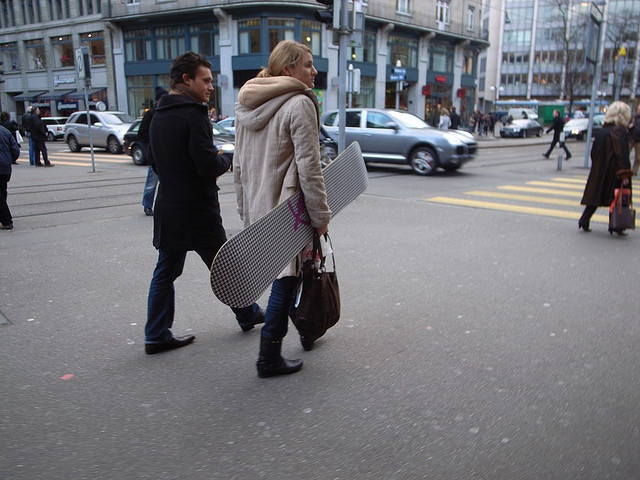Describe the objects in this image and their specific colors. I can see people in black, gray, darkgray, and maroon tones, people in black, darkgray, gray, and maroon tones, snowboard in black and gray tones, car in black, lavender, and gray tones, and people in black, darkgray, gray, and maroon tones in this image. 